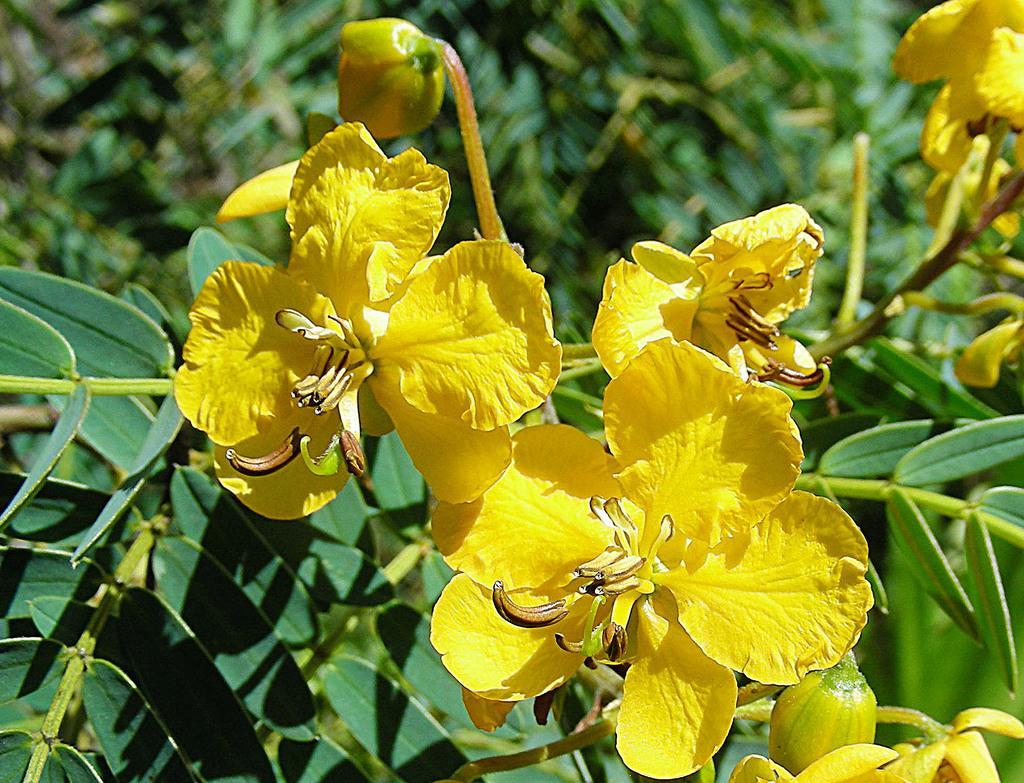Please provide a concise description of this image. In the image there are yellow flowers to the plant. 